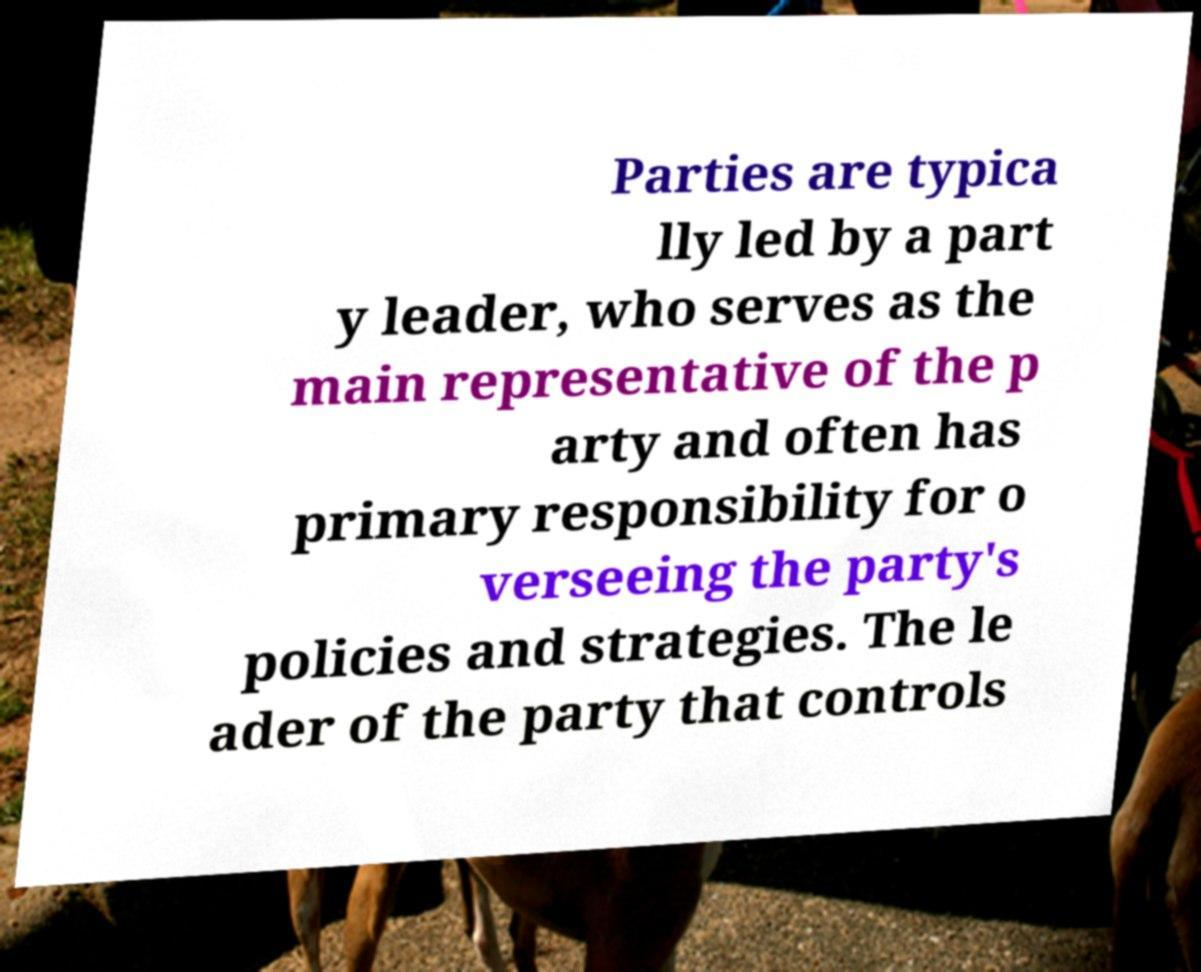There's text embedded in this image that I need extracted. Can you transcribe it verbatim? Parties are typica lly led by a part y leader, who serves as the main representative of the p arty and often has primary responsibility for o verseeing the party's policies and strategies. The le ader of the party that controls 